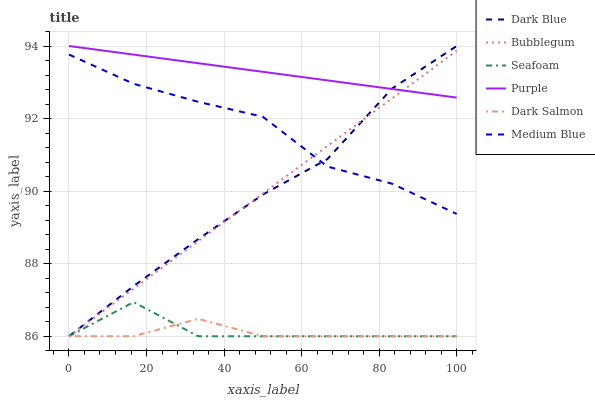Does Dark Salmon have the minimum area under the curve?
Answer yes or no. Yes. Does Purple have the maximum area under the curve?
Answer yes or no. Yes. Does Medium Blue have the minimum area under the curve?
Answer yes or no. No. Does Medium Blue have the maximum area under the curve?
Answer yes or no. No. Is Bubblegum the smoothest?
Answer yes or no. Yes. Is Seafoam the roughest?
Answer yes or no. Yes. Is Medium Blue the smoothest?
Answer yes or no. No. Is Medium Blue the roughest?
Answer yes or no. No. Does Seafoam have the lowest value?
Answer yes or no. Yes. Does Medium Blue have the lowest value?
Answer yes or no. No. Does Dark Blue have the highest value?
Answer yes or no. Yes. Does Medium Blue have the highest value?
Answer yes or no. No. Is Seafoam less than Medium Blue?
Answer yes or no. Yes. Is Purple greater than Seafoam?
Answer yes or no. Yes. Does Bubblegum intersect Purple?
Answer yes or no. Yes. Is Bubblegum less than Purple?
Answer yes or no. No. Is Bubblegum greater than Purple?
Answer yes or no. No. Does Seafoam intersect Medium Blue?
Answer yes or no. No. 